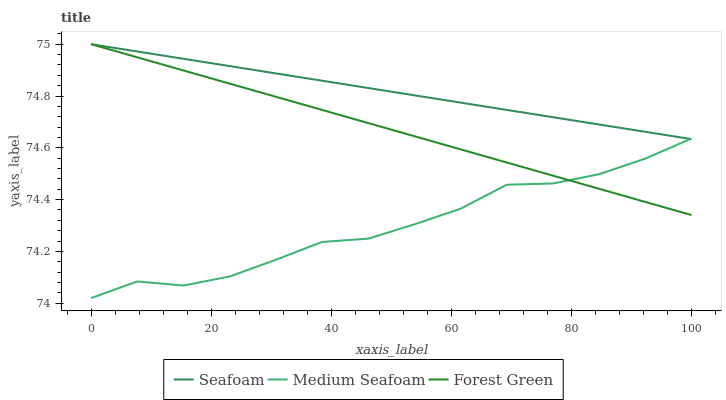Does Medium Seafoam have the minimum area under the curve?
Answer yes or no. Yes. Does Seafoam have the maximum area under the curve?
Answer yes or no. Yes. Does Seafoam have the minimum area under the curve?
Answer yes or no. No. Does Medium Seafoam have the maximum area under the curve?
Answer yes or no. No. Is Forest Green the smoothest?
Answer yes or no. Yes. Is Medium Seafoam the roughest?
Answer yes or no. Yes. Is Seafoam the smoothest?
Answer yes or no. No. Is Seafoam the roughest?
Answer yes or no. No. Does Seafoam have the lowest value?
Answer yes or no. No. Does Seafoam have the highest value?
Answer yes or no. Yes. Does Medium Seafoam have the highest value?
Answer yes or no. No. Does Medium Seafoam intersect Forest Green?
Answer yes or no. Yes. Is Medium Seafoam less than Forest Green?
Answer yes or no. No. Is Medium Seafoam greater than Forest Green?
Answer yes or no. No. 